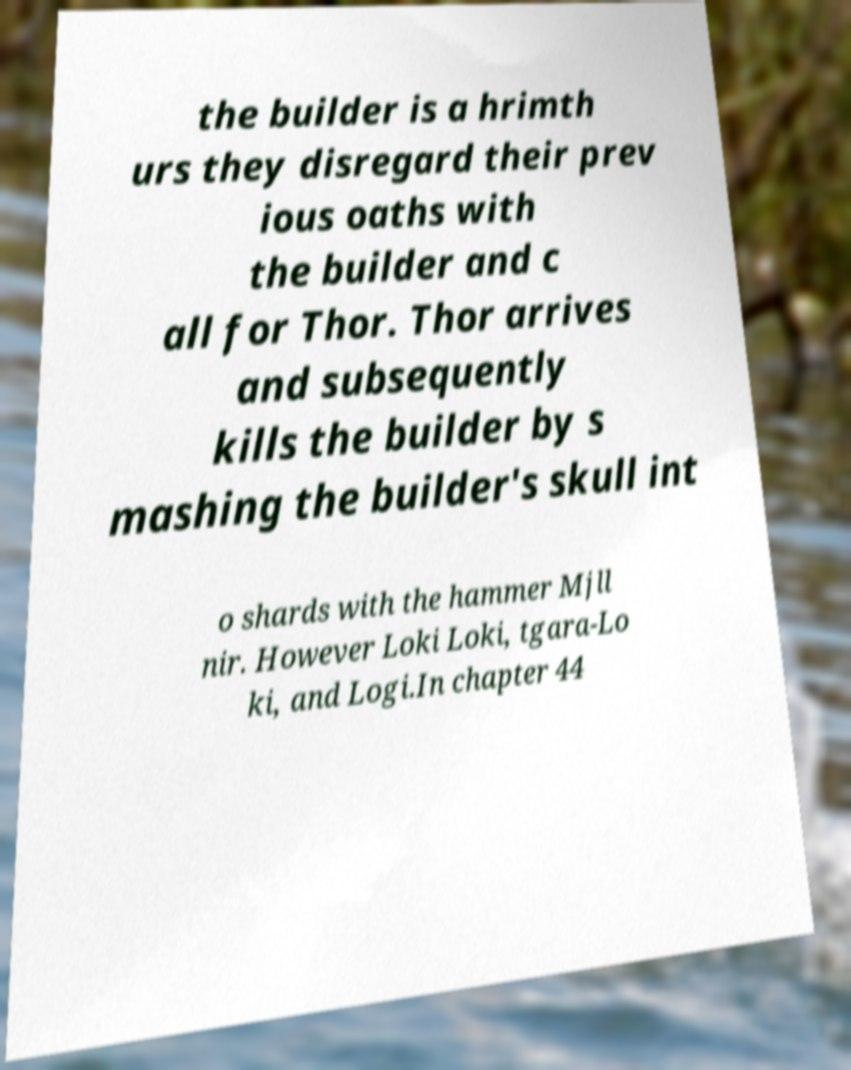Could you assist in decoding the text presented in this image and type it out clearly? the builder is a hrimth urs they disregard their prev ious oaths with the builder and c all for Thor. Thor arrives and subsequently kills the builder by s mashing the builder's skull int o shards with the hammer Mjll nir. However Loki Loki, tgara-Lo ki, and Logi.In chapter 44 